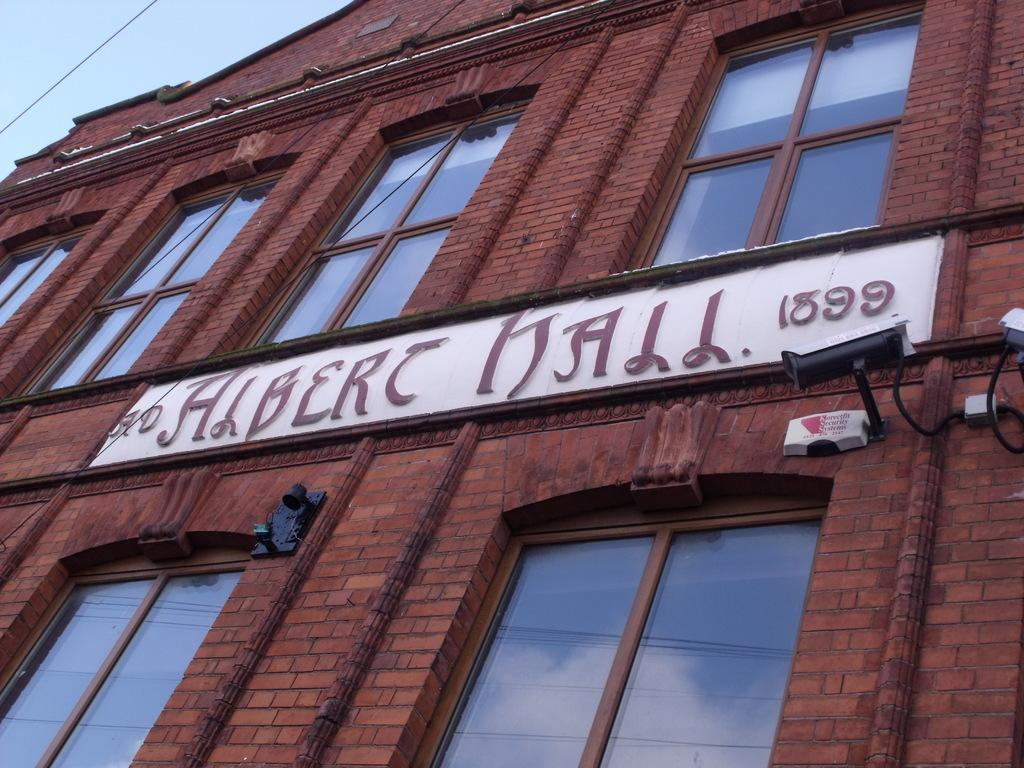What type of building is shown in the image? The building in the image has glass windows. What can be seen near the building? A camera is visible in the image. Is there any additional information about the building? Yes, a board is attached to the building. How does the duck feel about the low temperature in the image? There is no duck present in the image, so it is not possible to determine how a duck might feel about the temperature. 